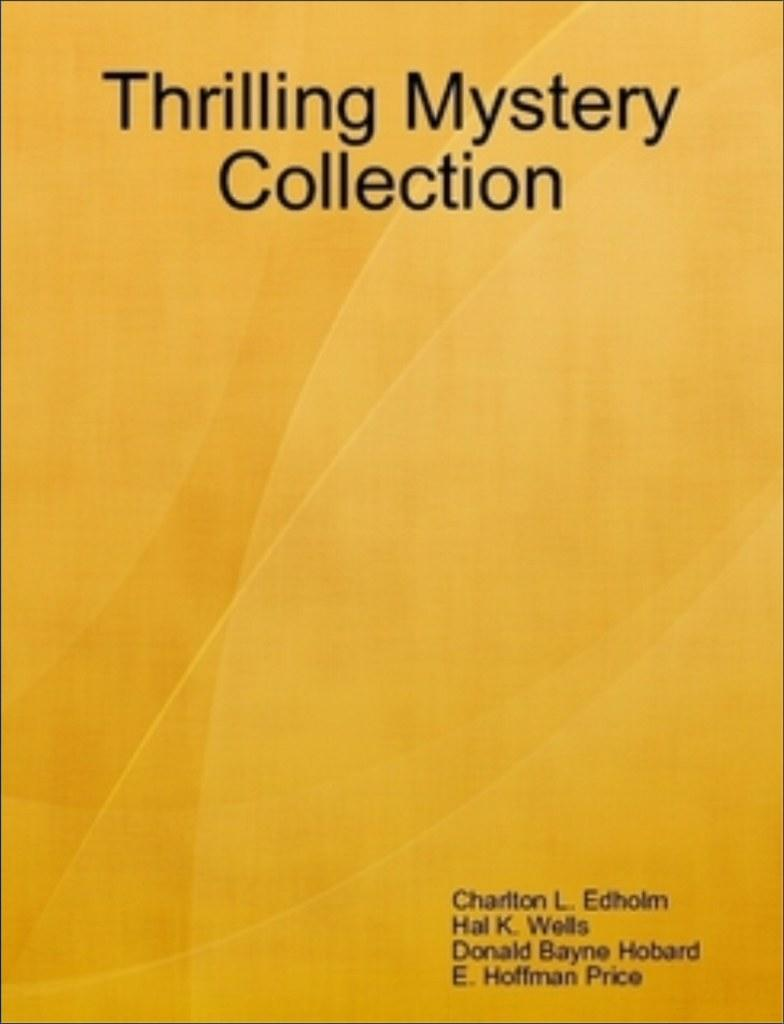<image>
Give a short and clear explanation of the subsequent image. The cover of Charlton L. Edholm's Thrilling Mystery Collection is a solid color. 